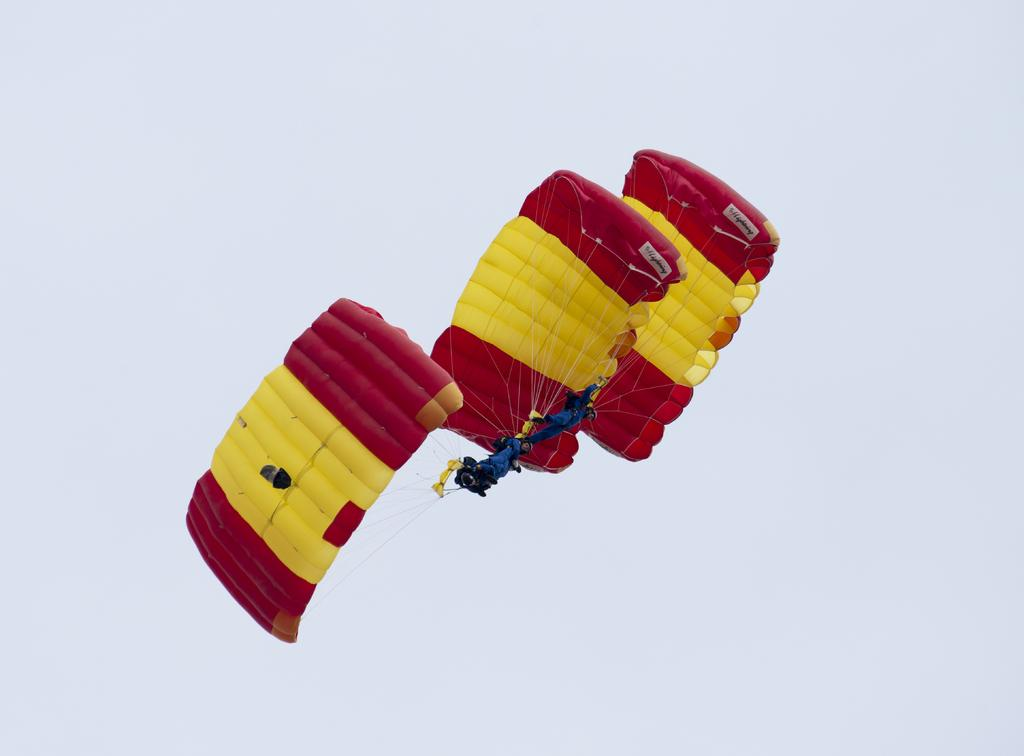What is the main object in the image? There is a red and yellow color parachute in the image. What is the parachute doing in the image? The parachute is flying in the air. What can be seen in the background of the image? The sky is visible in the background of the image. What type of whistle can be heard in the image? There is no whistle present in the image, and therefore no sound can be heard. What is the source of the flame in the image? There is no flame present in the image. 